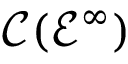Convert formula to latex. <formula><loc_0><loc_0><loc_500><loc_500>{ \mathcal { C } } ( { \mathcal { E } } ^ { \infty } )</formula> 